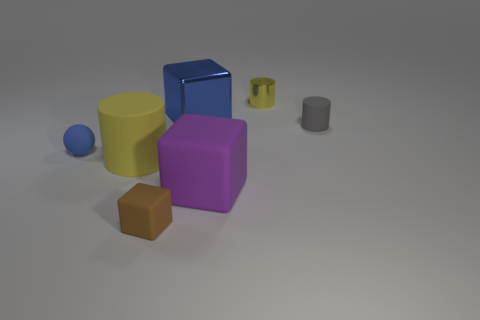Is the color of the large matte cylinder the same as the small cylinder left of the tiny gray matte object?
Your response must be concise. Yes. What color is the large matte cylinder?
Give a very brief answer. Yellow. Are there any other things that are the same shape as the tiny blue rubber thing?
Offer a terse response. No. What color is the shiny object that is the same shape as the large purple matte thing?
Keep it short and to the point. Blue. Is the shape of the purple thing the same as the small yellow thing?
Give a very brief answer. No. What number of cubes are small matte objects or cyan things?
Offer a very short reply. 1. The small cylinder that is made of the same material as the brown block is what color?
Give a very brief answer. Gray. There is a yellow object behind the matte sphere; is its size the same as the gray cylinder?
Provide a succinct answer. Yes. Are the small cube and the yellow cylinder that is behind the blue matte ball made of the same material?
Ensure brevity in your answer.  No. There is a cylinder on the left side of the brown matte object; what color is it?
Your answer should be compact. Yellow. 